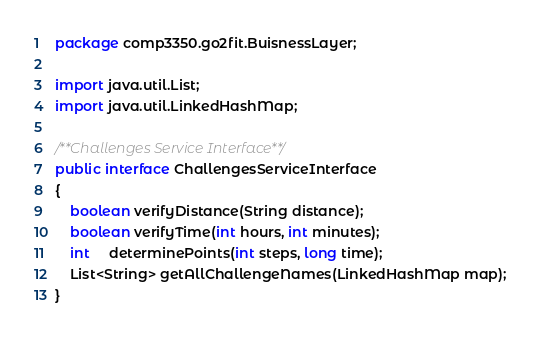<code> <loc_0><loc_0><loc_500><loc_500><_Java_>package comp3350.go2fit.BuisnessLayer;

import java.util.List;
import java.util.LinkedHashMap;

/**Challenges Service Interface**/
public interface ChallengesServiceInterface
{
    boolean verifyDistance(String distance);
    boolean verifyTime(int hours, int minutes);
    int     determinePoints(int steps, long time);
    List<String> getAllChallengeNames(LinkedHashMap map);
}
</code> 